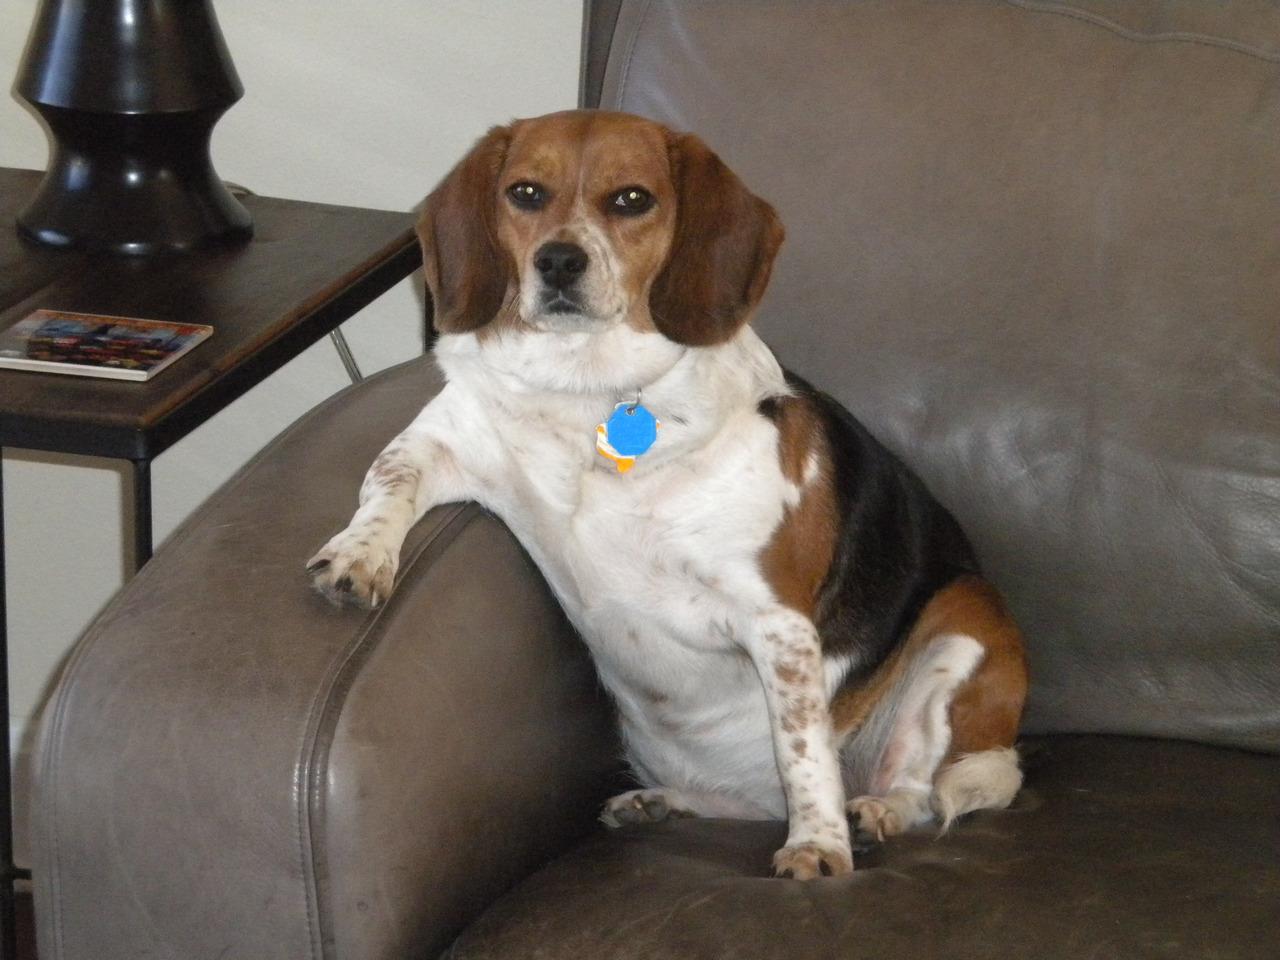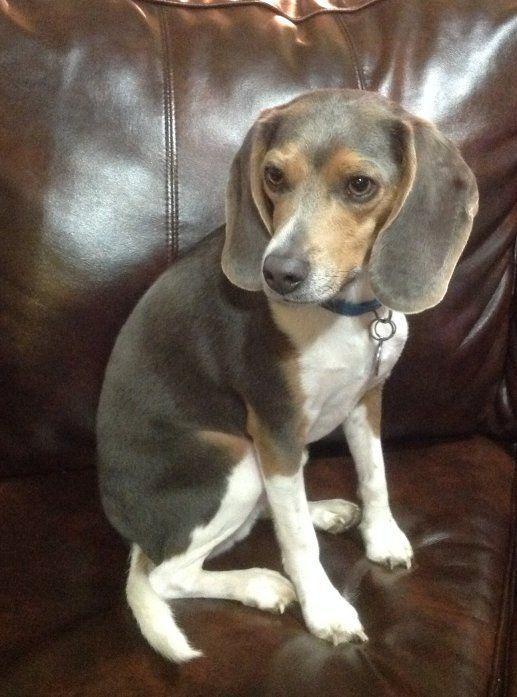The first image is the image on the left, the second image is the image on the right. For the images displayed, is the sentence "Each image contains one hound dog posing on furniture, and at least one dog is on leather upholstery." factually correct? Answer yes or no. Yes. The first image is the image on the left, the second image is the image on the right. Considering the images on both sides, is "The dog in one of the images has a red collar." valid? Answer yes or no. No. 